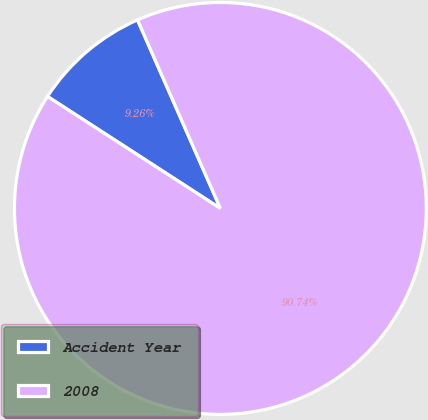Convert chart to OTSL. <chart><loc_0><loc_0><loc_500><loc_500><pie_chart><fcel>Accident Year<fcel>2008<nl><fcel>9.26%<fcel>90.74%<nl></chart> 